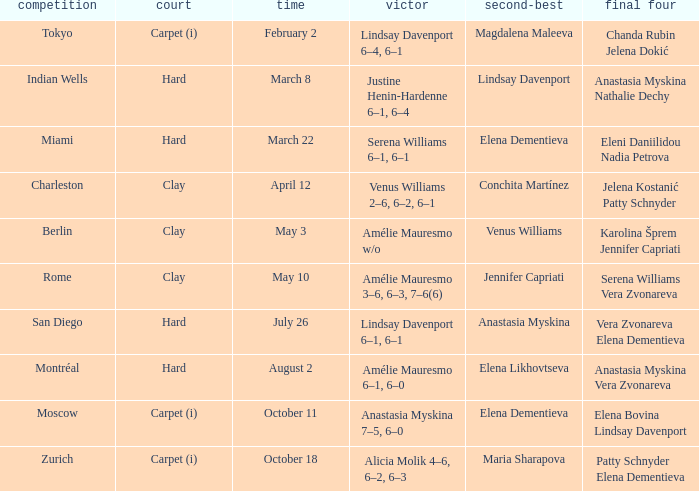Who was the finalist of the hard surface tournament in Miami? Elena Dementieva. 